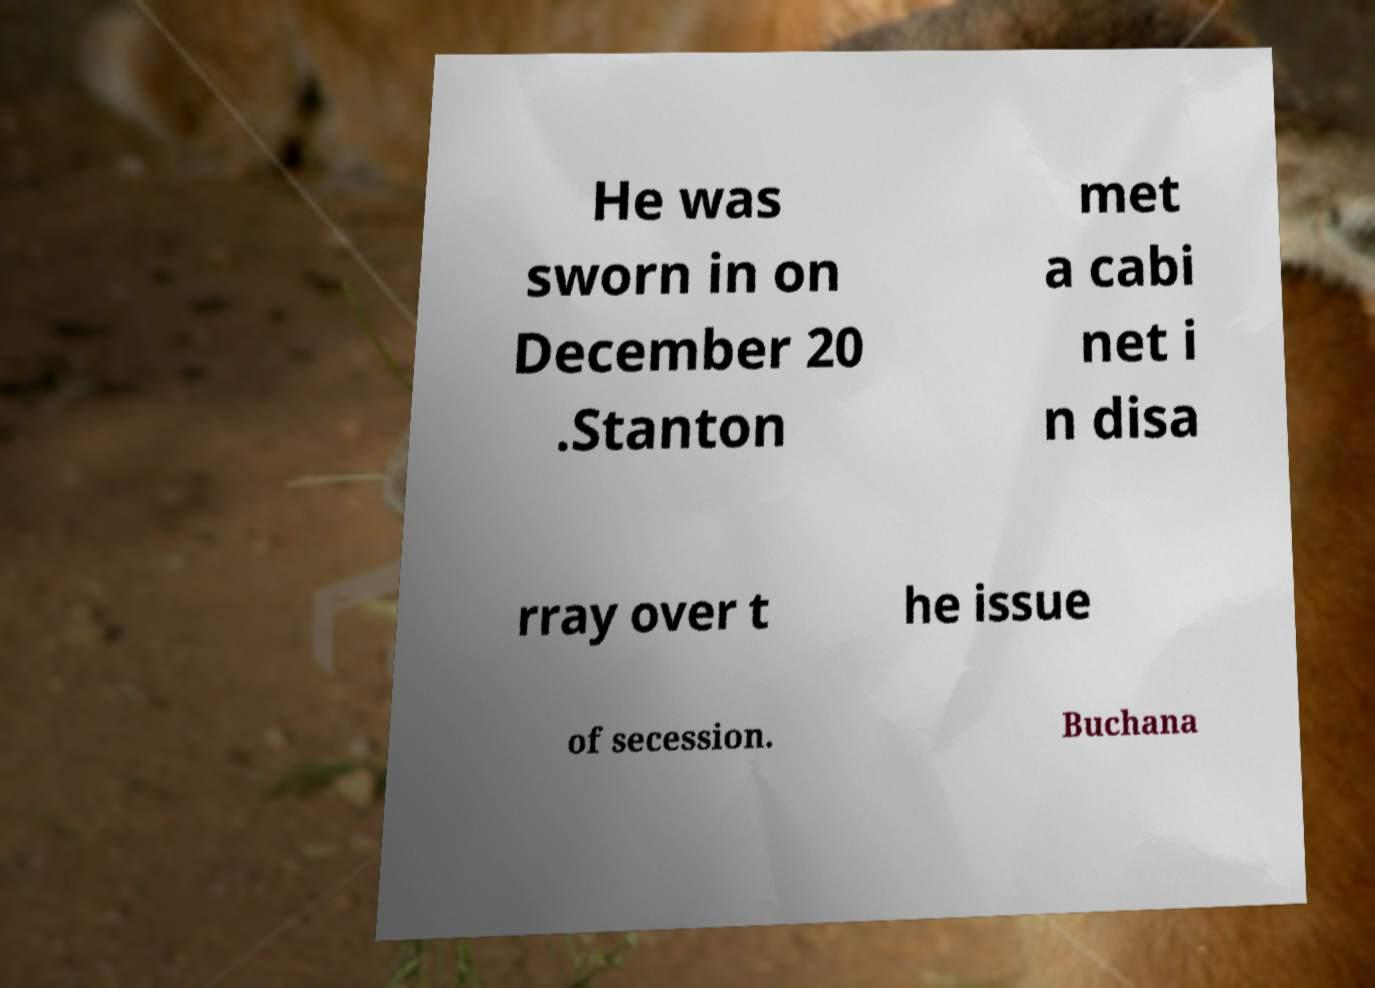There's text embedded in this image that I need extracted. Can you transcribe it verbatim? He was sworn in on December 20 .Stanton met a cabi net i n disa rray over t he issue of secession. Buchana 